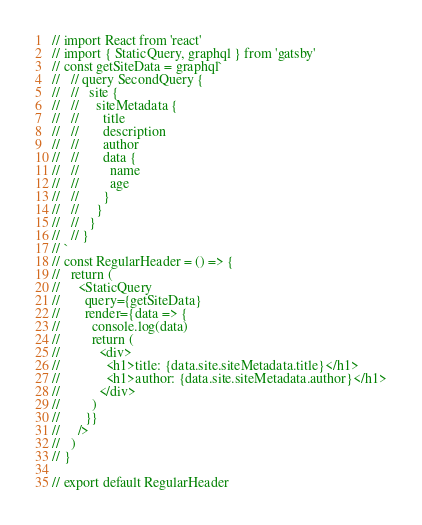<code> <loc_0><loc_0><loc_500><loc_500><_JavaScript_>// import React from 'react'
// import { StaticQuery, graphql } from 'gatsby'
// const getSiteData = graphql`
//   // query SecondQuery {
//   //   site {
//   //     siteMetadata {
//   //       title
//   //       description
//   //       author
//   //       data {
//   //         name
//   //         age
//   //       }
//   //     }
//   //   }
//   // }
// `
// const RegularHeader = () => {
//   return (
//     <StaticQuery
//       query={getSiteData}
//       render={data => {
//         console.log(data)
//         return (
//           <div>
//             <h1>title: {data.site.siteMetadata.title}</h1>
//             <h1>author: {data.site.siteMetadata.author}</h1>
//           </div>
//         )
//       }}
//     />
//   )
// }

// export default RegularHeader
</code> 